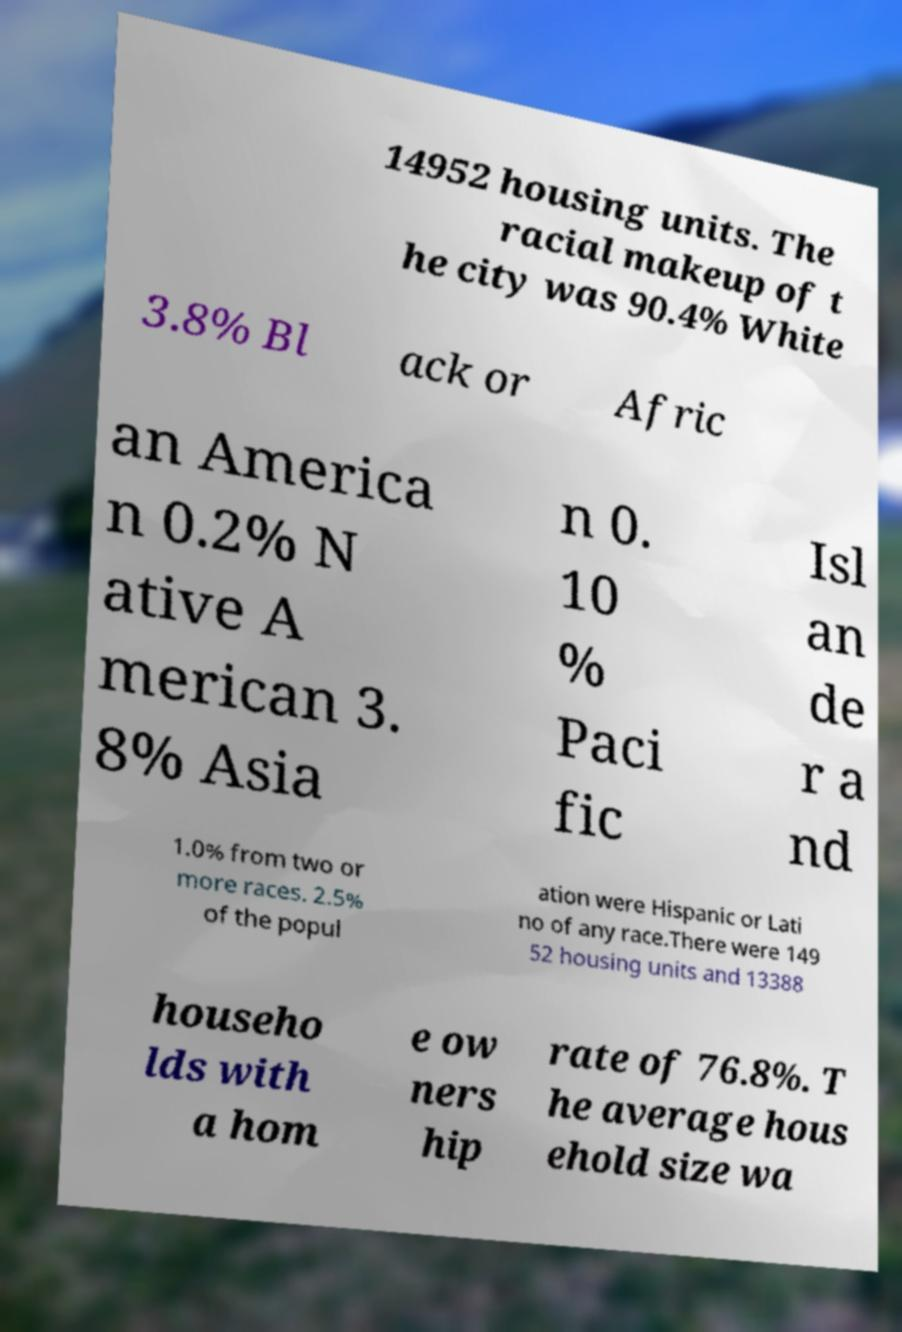Could you assist in decoding the text presented in this image and type it out clearly? 14952 housing units. The racial makeup of t he city was 90.4% White 3.8% Bl ack or Afric an America n 0.2% N ative A merican 3. 8% Asia n 0. 10 % Paci fic Isl an de r a nd 1.0% from two or more races. 2.5% of the popul ation were Hispanic or Lati no of any race.There were 149 52 housing units and 13388 househo lds with a hom e ow ners hip rate of 76.8%. T he average hous ehold size wa 